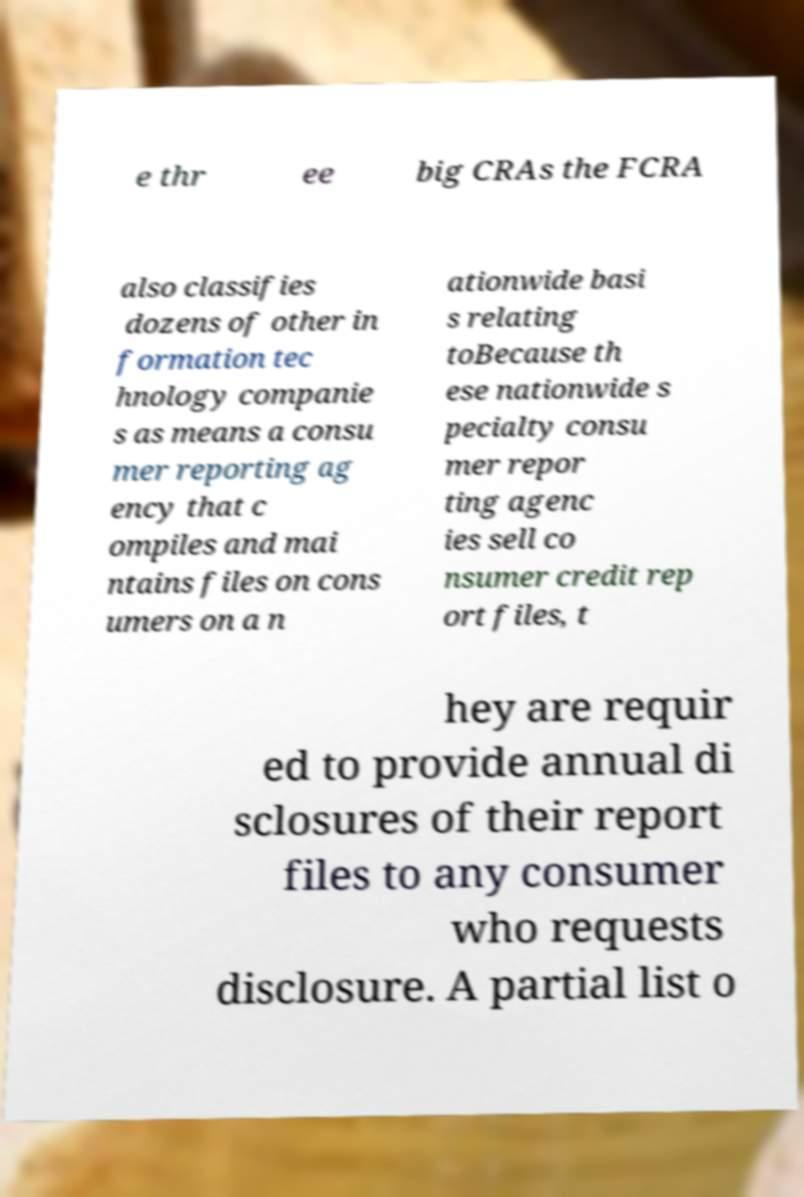Please identify and transcribe the text found in this image. e thr ee big CRAs the FCRA also classifies dozens of other in formation tec hnology companie s as means a consu mer reporting ag ency that c ompiles and mai ntains files on cons umers on a n ationwide basi s relating toBecause th ese nationwide s pecialty consu mer repor ting agenc ies sell co nsumer credit rep ort files, t hey are requir ed to provide annual di sclosures of their report files to any consumer who requests disclosure. A partial list o 